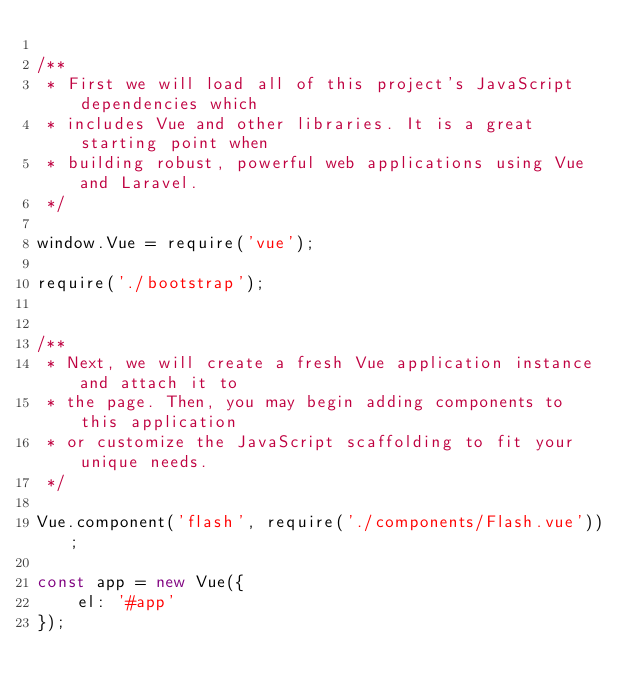Convert code to text. <code><loc_0><loc_0><loc_500><loc_500><_JavaScript_>
/**
 * First we will load all of this project's JavaScript dependencies which
 * includes Vue and other libraries. It is a great starting point when
 * building robust, powerful web applications using Vue and Laravel.
 */

window.Vue = require('vue');

require('./bootstrap');


/**
 * Next, we will create a fresh Vue application instance and attach it to
 * the page. Then, you may begin adding components to this application
 * or customize the JavaScript scaffolding to fit your unique needs.
 */

Vue.component('flash', require('./components/Flash.vue'));

const app = new Vue({
    el: '#app'
});
</code> 